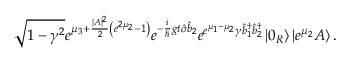<formula> <loc_0><loc_0><loc_500><loc_500>\sqrt { 1 - \gamma ^ { 2 } } e ^ { \mu _ { 3 } + \frac { | A | ^ { 2 } } { 2 } \left ( e ^ { 2 \mu _ { 2 } } - 1 \right ) } e ^ { - \frac { i } { \hslash } g t \hat { \sigma } \hat { b } _ { 2 } } e ^ { e ^ { \mu _ { 1 } - \mu _ { 2 } } \gamma \hat { b } _ { 1 } ^ { \dagger } \hat { b } _ { 2 } ^ { \dagger } } \left | 0 _ { R } \right \rangle \left | e ^ { \mu _ { 2 } } A \right \rangle .</formula> 